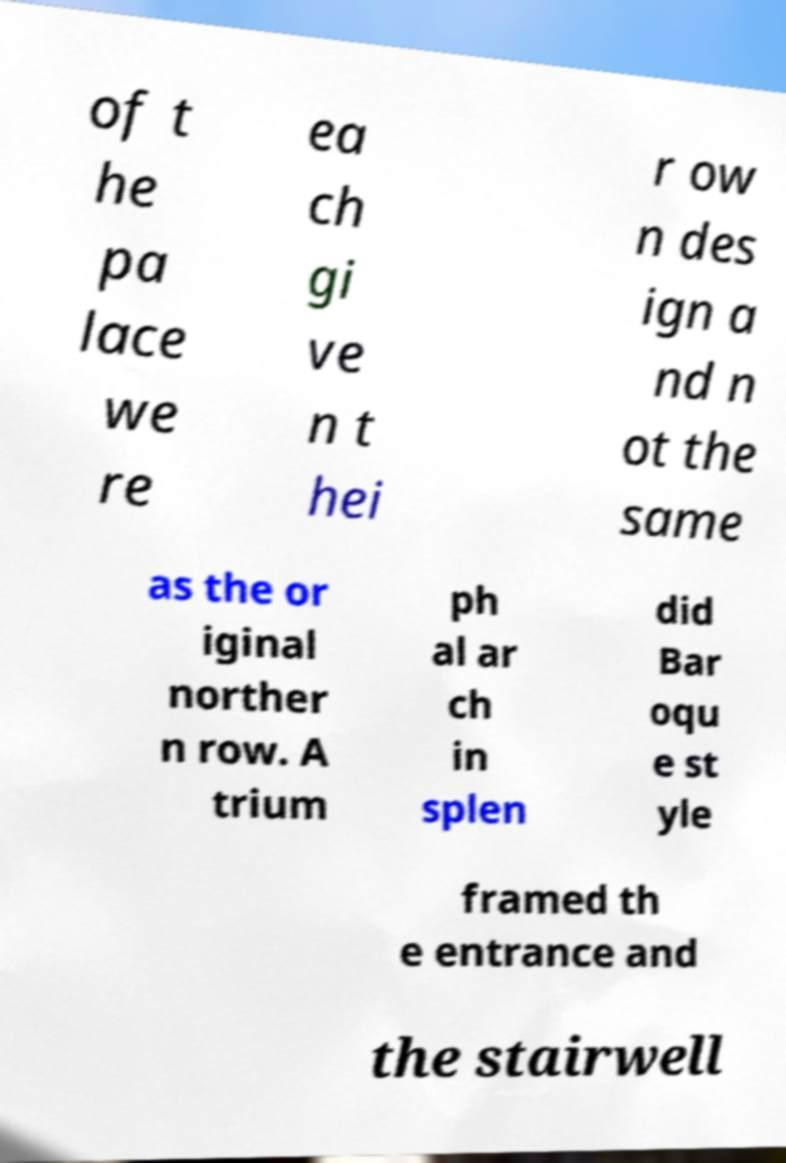Could you extract and type out the text from this image? of t he pa lace we re ea ch gi ve n t hei r ow n des ign a nd n ot the same as the or iginal norther n row. A trium ph al ar ch in splen did Bar oqu e st yle framed th e entrance and the stairwell 